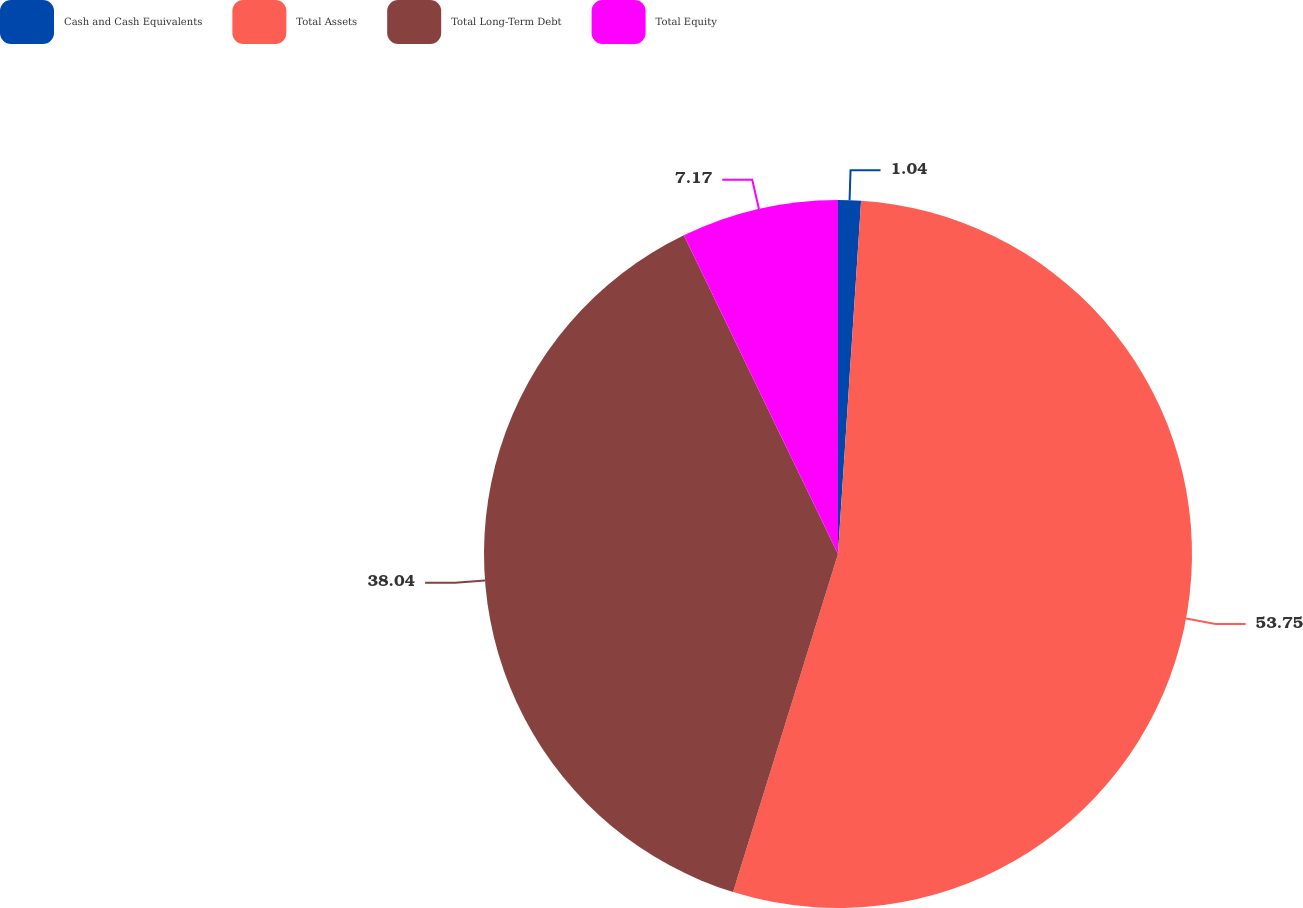Convert chart to OTSL. <chart><loc_0><loc_0><loc_500><loc_500><pie_chart><fcel>Cash and Cash Equivalents<fcel>Total Assets<fcel>Total Long-Term Debt<fcel>Total Equity<nl><fcel>1.04%<fcel>53.75%<fcel>38.04%<fcel>7.17%<nl></chart> 